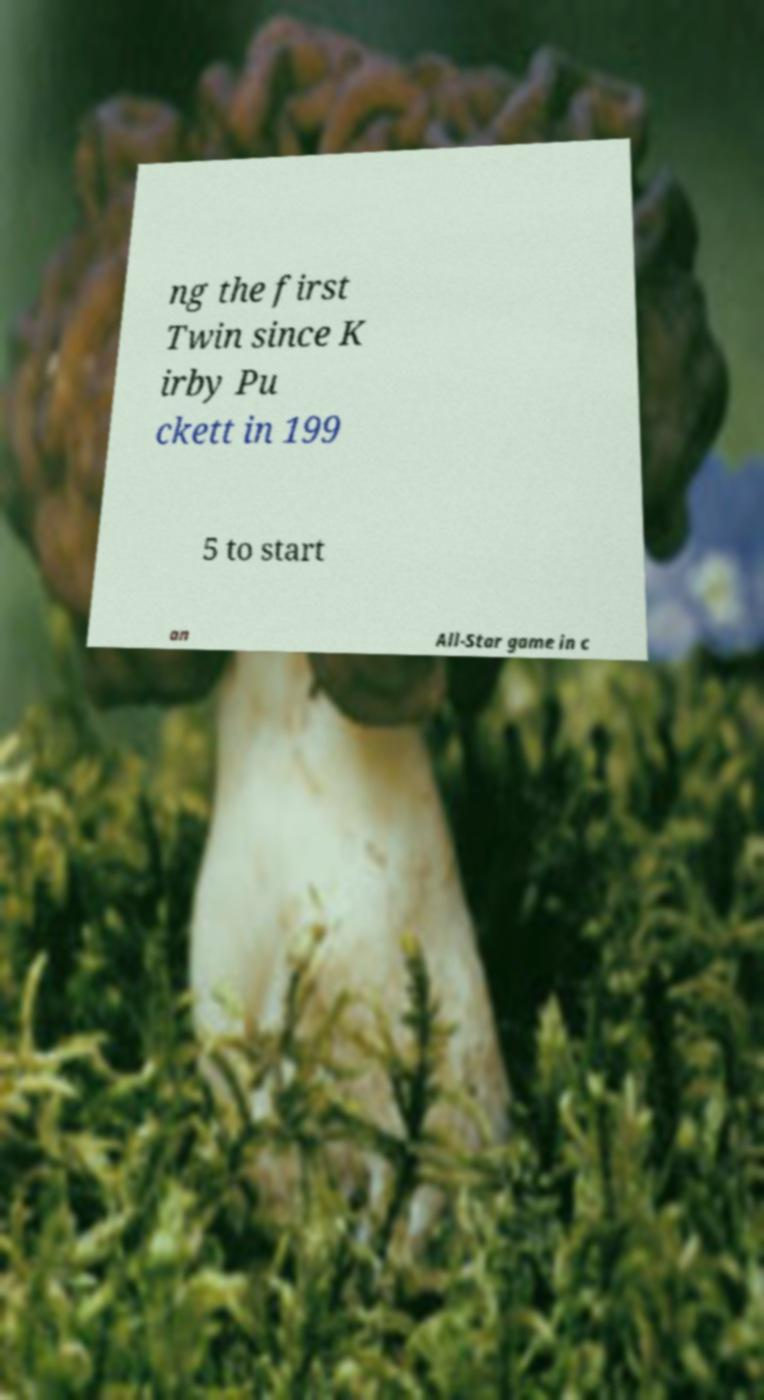Could you assist in decoding the text presented in this image and type it out clearly? ng the first Twin since K irby Pu ckett in 199 5 to start an All-Star game in c 